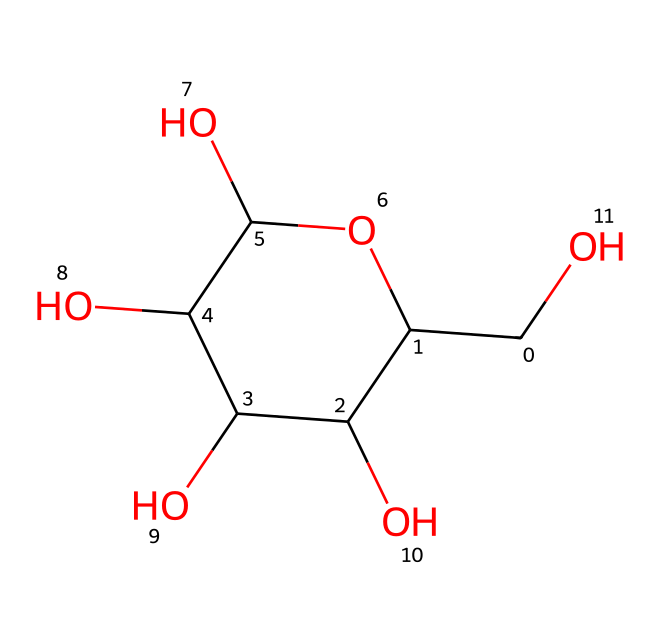how many hydroxyl groups are present in glucose? The SMILES representation indicates the presence of multiple hydroxyl groups (-OH). Counting them reveals there are five -OH groups in the structure of glucose.
Answer: five what is the molecular formula of glucose? Based on the structure and counting the different types of atoms (C, H, O), the molecular formula can be derived as C6H12O6.
Answer: C6H12O6 what type of sugar is glucose classified as? Glucose is classified as a monosaccharide, which is a single sugar unit. This is evident from its simple structure, which is not comprised of multiple sugar units.
Answer: monosaccharide how many carbon atoms does glucose contain? By analyzing the SMILES representation, one can count that there are six carbon atoms represented in the structure of glucose.
Answer: six what shape or structure does glucose typically assume? Glucose typically assumes a cyclic structure (specifically a pyranose form) due to the way its hydroxyl and carbon groups interact in solution, as illustrated by the formation of a ring structure in the SMILES.
Answer: cyclic what is the significance of glucose in sports energy drinks? Glucose is essential for providing rapid energy due to its quick absorption in the body, making it a preferred carbohydrate source in energy drinks for athletes.
Answer: rapid energy what functional group is mainly responsible for glucose's solubility in water? The hydroxyl (-OH) groups in glucose are responsible for its solubility in water due to hydrogen bonding with water molecules, allowing for good dissolution.
Answer: hydroxyl groups 